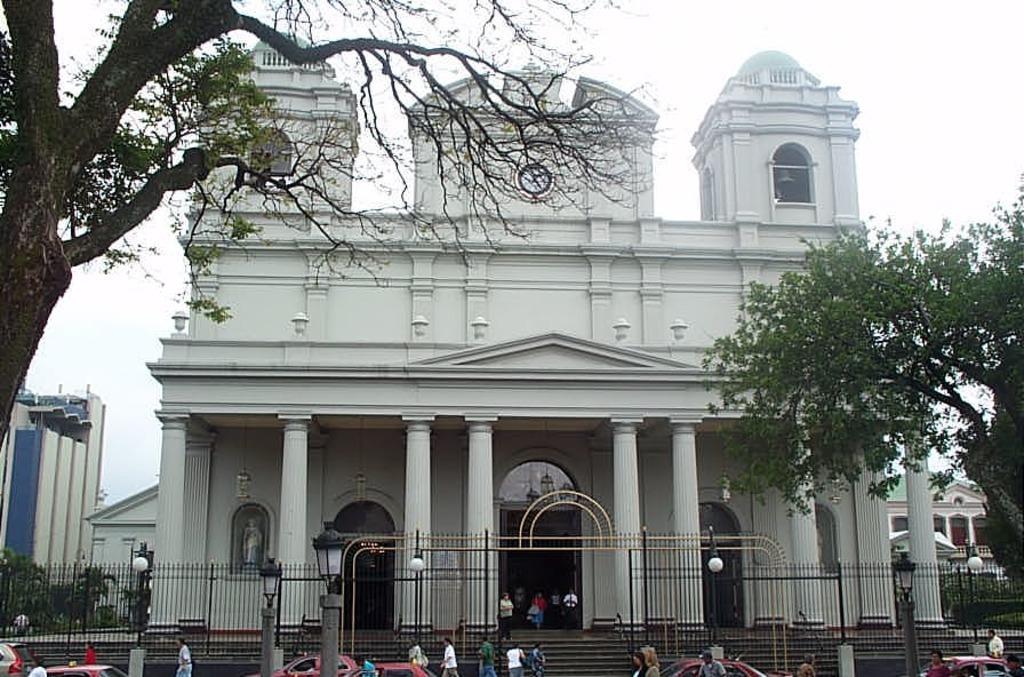In one or two sentences, can you explain what this image depicts? In this picture we can see a white color building with big pillar in the front. Above we can see clock. In the front bottom side we can see black color fencing grill and some steps. 